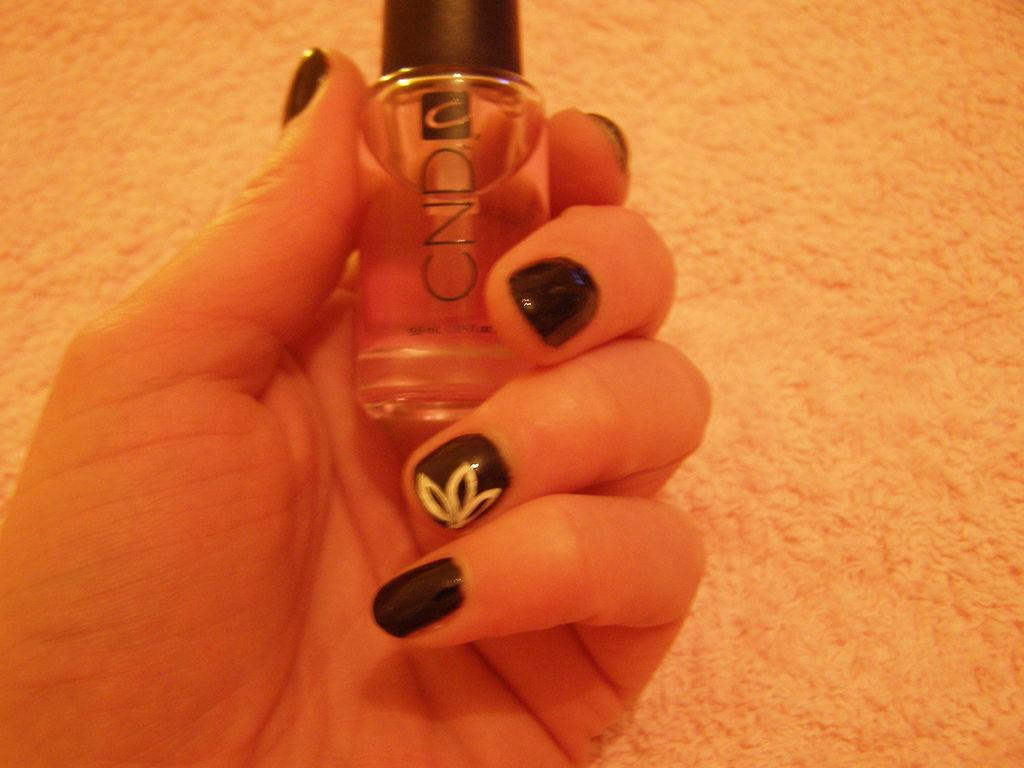<image>
Create a compact narrative representing the image presented. A woman's hand with black nail polish on holds a bottle of CND nail polish. 